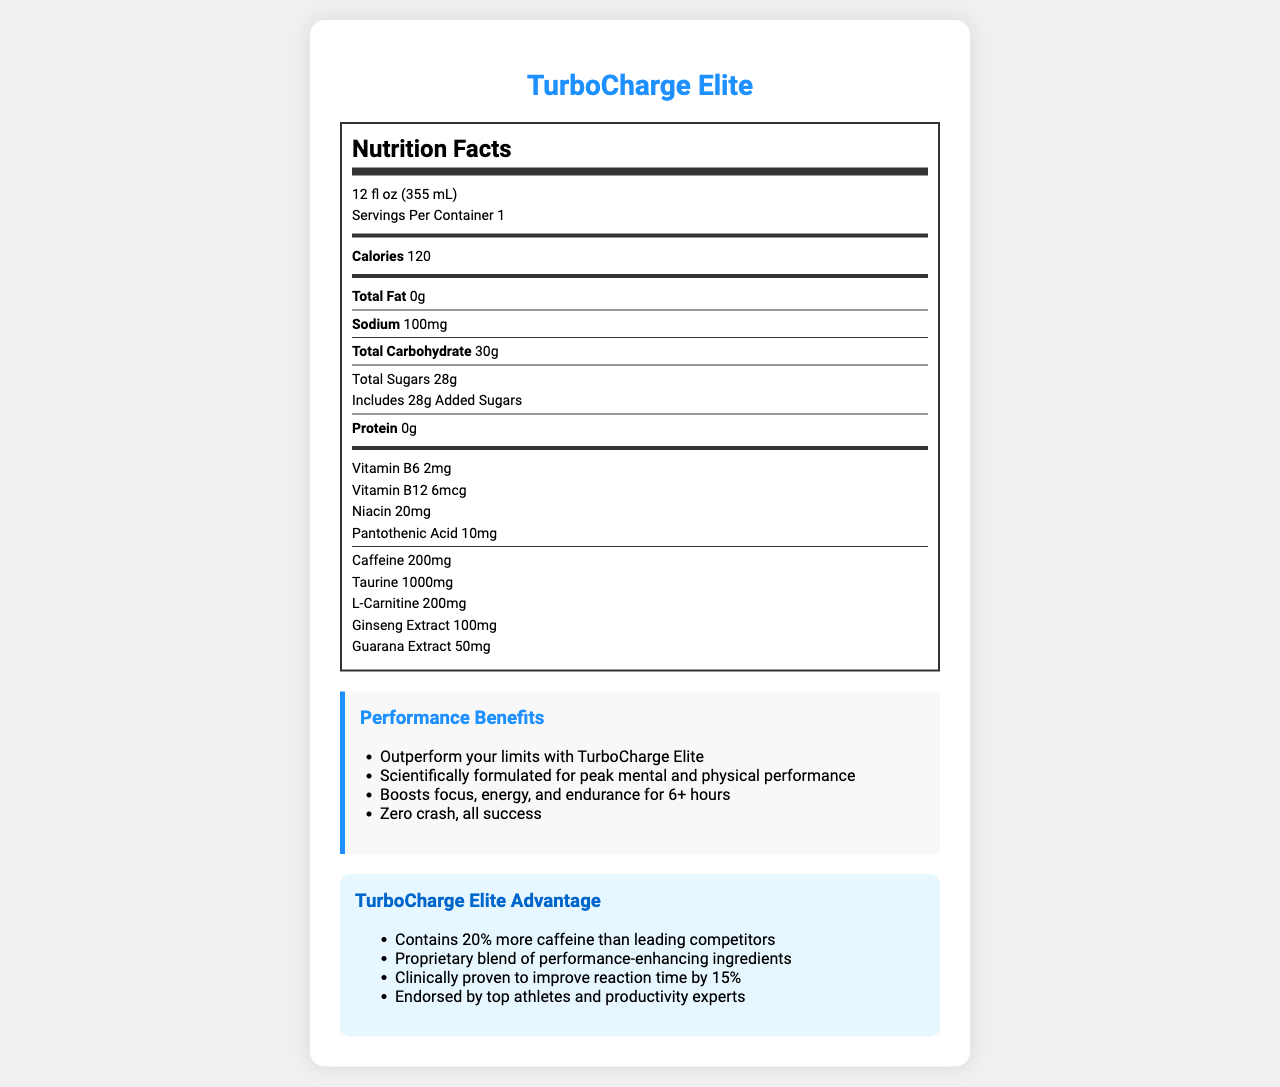what is the serving size of TurboCharge Elite? The serving size is stated at the top of the Nutrition Facts as "12 fl oz (355 mL)".
Answer: 12 fl oz (355 mL) how many calories are in one serving of TurboCharge Elite? The document lists the calories as 120 per serving.
Answer: 120 what is the total carbohydrate content per serving? The Nutrition Facts state that the total carbohydrate per serving is 30g.
Answer: 30g how much caffeine is in TurboCharge Elite? The Nutrition Facts detail that there are 200mg of caffeine in the product.
Answer: 200mg how many grams of sugar does TurboCharge Elite contain? The document specifies that the total sugars content is 28g.
Answer: 28g what vitamins are included in TurboCharge Elite? The Nutrition Facts list Vitamin B6 (2mg), Vitamin B12 (6mcg), Niacin (20mg), and Pantothenic Acid (10mg).
Answer: Vitamin B6, Vitamin B12, Niacin, Pantothenic Acid which of the following is not a target audience for TurboCharge Elite? A. High-achieving professionals B. Competitive athletes C. People looking to relax D. Students seeking academic edge The target audience does not include people looking to relax, but it does include high-achieving professionals, competitive athletes, and students seeking an academic edge.
Answer: C which feature is included in the packaging of TurboCharge Elite? A. Sleek, premium design B. Built-in straw C. Plastic casing D. Unscrewable cap The packaging highlights list a sleek, premium design among its features.
Answer: A is TurboCharge Elite marketed as having a zero crash effect? One of the marketing claims states "Zero crash, all success".
Answer: Yes what is the main idea of this document? The document is a detailed overview of TurboCharge Elite, including its nutrition contents, advantages, marketing claims, target audience, and distribution channels.
Answer: The document provides detailed Nutrition Facts, performance benefits, competitive edges, target audience, product benefits, packaging highlights, and distribution channels for TurboCharge Elite, an energy drink designed for peak mental and physical performance. is the caffeine content in TurboCharge Elite higher than its leading competitors? The competitive edge section mentions that TurboCharge Elite contains 20% more caffeine than leading competitors.
Answer: Yes what is the distribution channel for TurboCharge Elite in educational institutions? The distribution channels include "University bookstores and campus shops".
Answer: University bookstores and campus shops does the container offer a resealable lid? The packaging highlights mention a resealable lid for maximum freshness.
Answer: Yes how many servings are included per container of TurboCharge Elite? The Nutrition Facts specifies that there is 1 serving per container.
Answer: 1 how does TurboCharge Elite claim to impact reaction time? According to the competitive edge section, TurboCharge Elite is clinically proven to improve reaction time by 15%.
Answer: Improves reaction time by 15% what type of container is TurboCharge Elite sold in? The packaging highlights mention that the can is made of 100% recyclable aluminum.
Answer: Aluminum can 